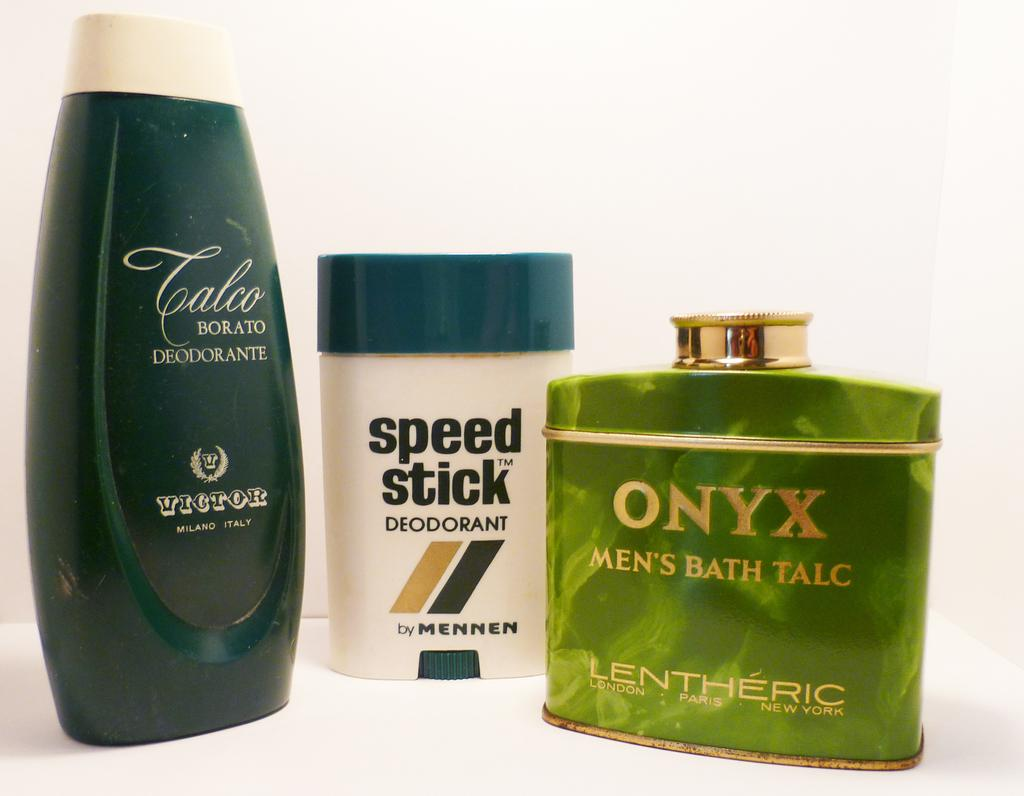<image>
Create a compact narrative representing the image presented. a green cologne bottle with the word Onyx on it 